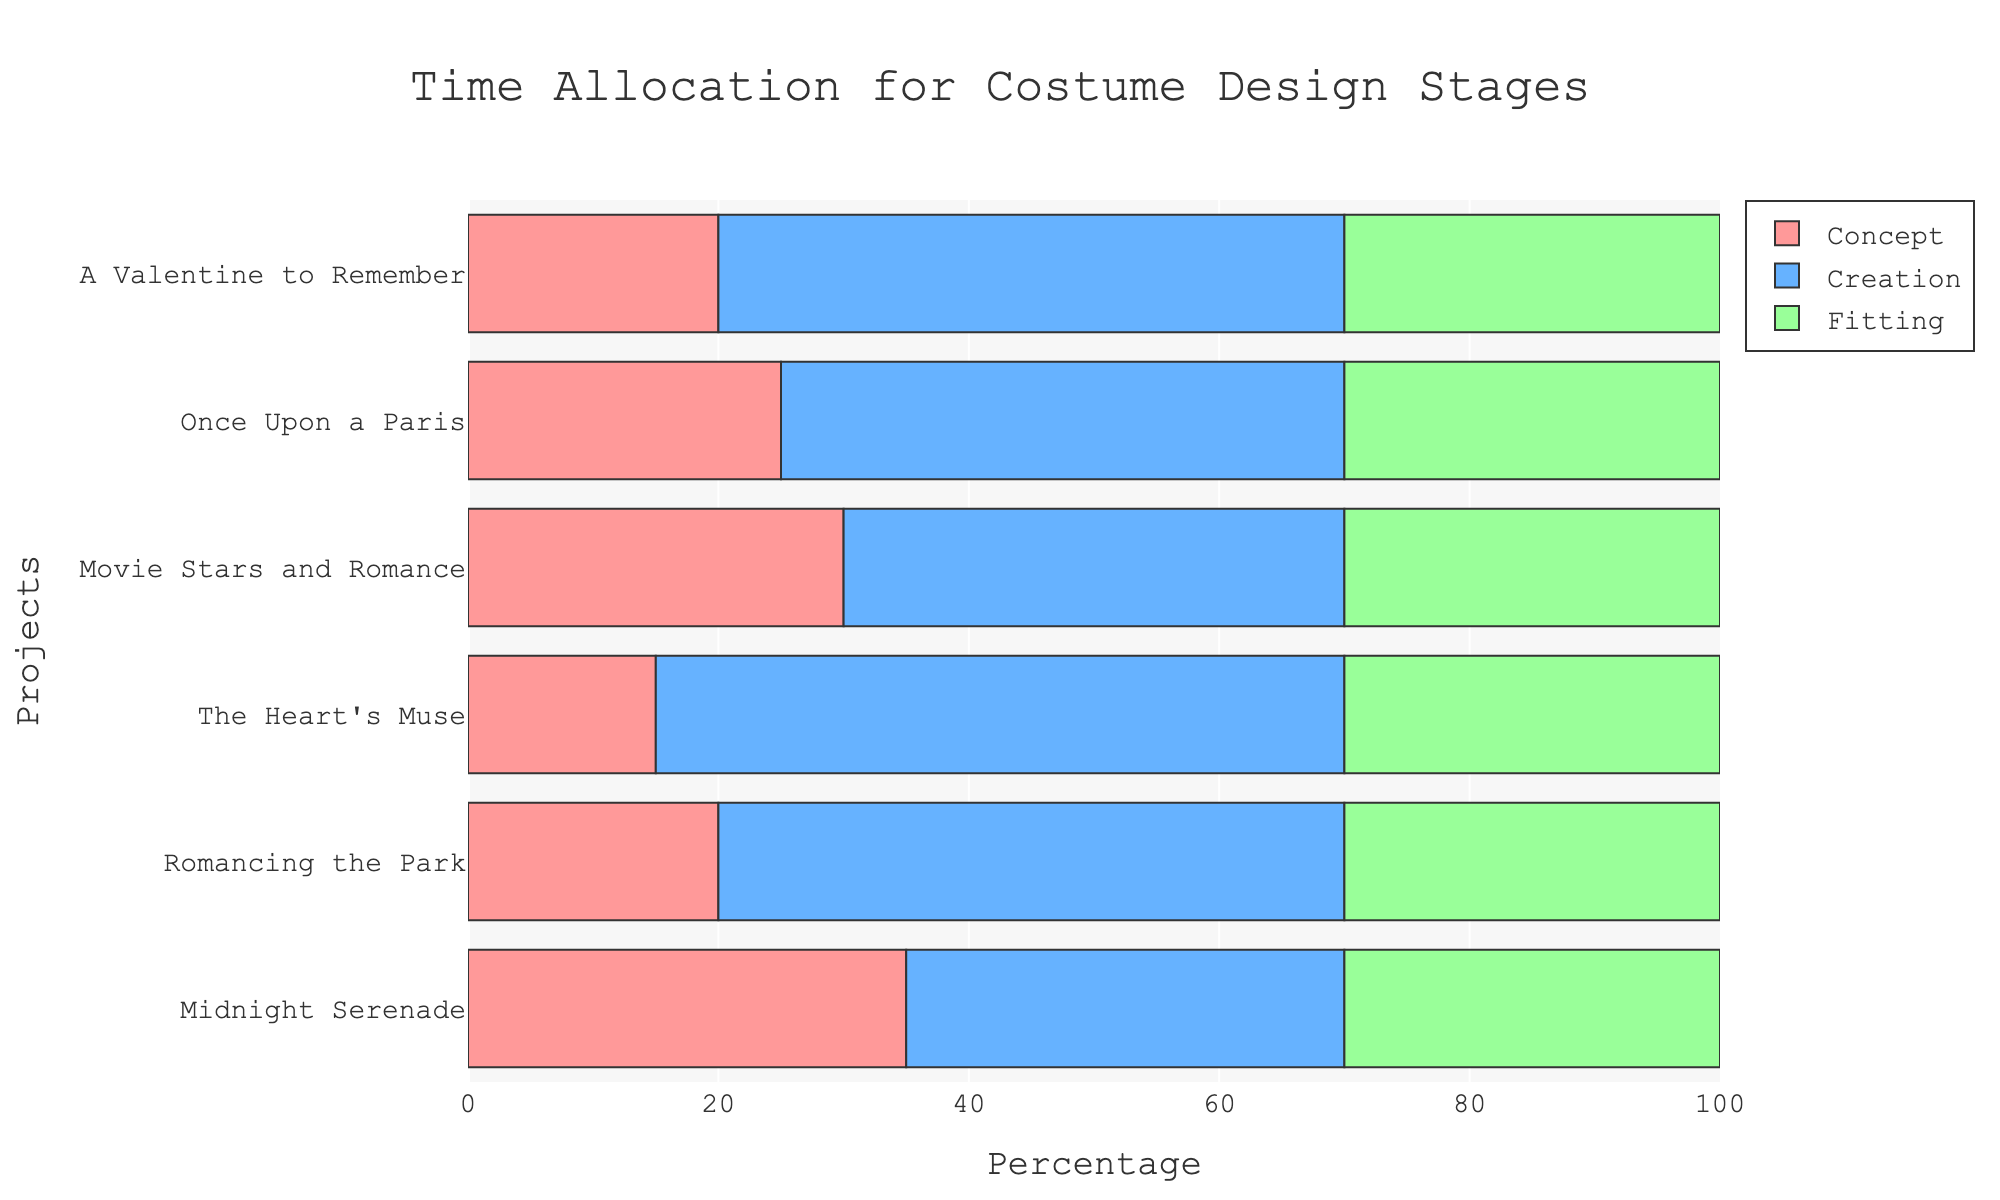what is the total percentage spent on the concept stage across all projects? Sum the percentages for the concept stage across all projects: 20 + 25 + 30 + 15 + 20 + 35 = 145
Answer: 145 which project spent the most percentage in the concept stage? By visually comparing the length of the red bars representing the concept stage across the projects, "Midnight Serenade" has the highest value at 35%.
Answer: Midnight Serenade which budget category dedicates the most time to creation? Sum the percentages for the creation stage within each budget category: Low: 50 + 55 = 105; Medium: 45 + 50 = 95; High: 40 + 35 = 75. Low has the highest total at 105%.
Answer: Low how does the time allocation for the fitting stage in "Movie Stars and Romance" compare to the fitting stage in "The Heart's Muse"? Both projects allocate 30% to the fitting stage.
Answer: They are equal which stage has the largest range of percentages across all projects? The concept stage ranges from 15% to 35% (a difference of 20%). The creation stage ranges from 35% to 55% (a difference of 20%). The fitting stage remains constant at 30% across all projects (a difference of 0%). Concept and creation stages both have the largest range.
Answer: Concept & creation what's the difference in time allocation for the creation stage between low-budget and high-budget projects? Compute the average for low and high budgets: Low: (50+55)/2 = 52.5; High: (40+35)/2 = 37.5; The difference is 52.5 - 37.5 = 15.
Answer: 15 how do the time allocations for the "Romancing the Park" project differ across the stages? For "Romancing the Park," identify the allocation of each stage: Concept: 20%, Creation: 50%, Fitting: 30%.
Answer: Concept: 20%, Creation: 50%, Fitting: 30% which project has the least percentage dedicated to the concept stage? By visually inspecting the lengths of the red bars, "The Heart's Muse" has the smallest percentage with 15%.
Answer: The Heart's Muse what is the average percentage allocated to the fitting stage across medium-budget projects? Sum the fitting percentages for medium-budget projects: (30 + 30) = 60; The number of medium-budget projects is 2. So, average is 60 / 2 = 30.
Answer: 30 which stage is most consistently allocated the same percentage of time across all projects? Check the consistency of stage allocations across all projects: Fitting stage consistently remains at 30% across all projects.
Answer: Fitting stage 